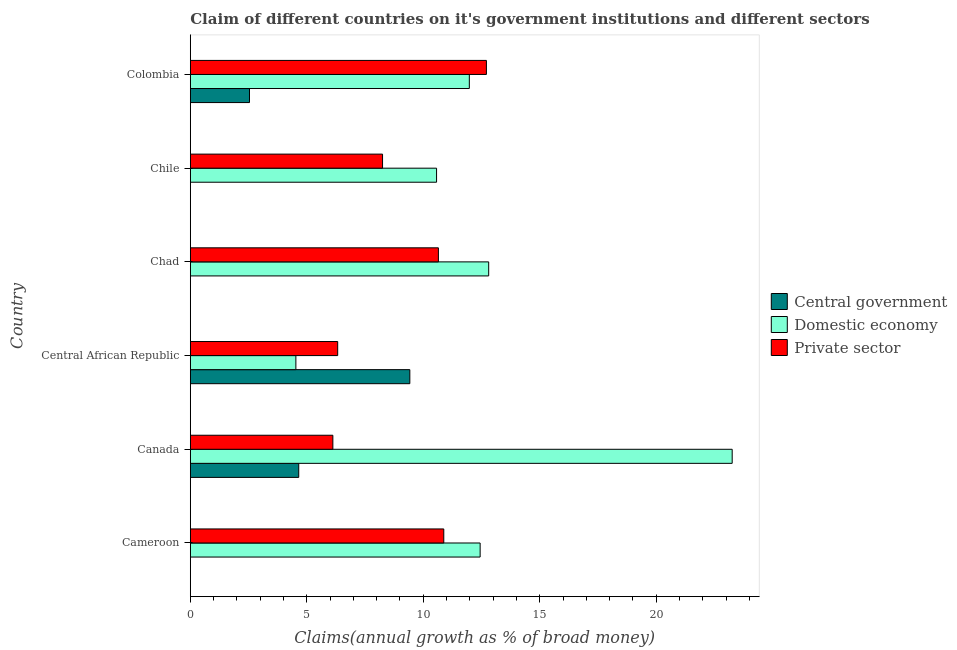Are the number of bars per tick equal to the number of legend labels?
Offer a terse response. No. Are the number of bars on each tick of the Y-axis equal?
Provide a short and direct response. No. How many bars are there on the 1st tick from the top?
Give a very brief answer. 3. How many bars are there on the 2nd tick from the bottom?
Offer a very short reply. 3. What is the label of the 5th group of bars from the top?
Your answer should be very brief. Canada. In how many cases, is the number of bars for a given country not equal to the number of legend labels?
Your answer should be very brief. 3. What is the percentage of claim on the domestic economy in Colombia?
Your answer should be very brief. 11.98. Across all countries, what is the maximum percentage of claim on the central government?
Your answer should be compact. 9.42. Across all countries, what is the minimum percentage of claim on the domestic economy?
Provide a succinct answer. 4.53. In which country was the percentage of claim on the domestic economy maximum?
Keep it short and to the point. Canada. What is the total percentage of claim on the central government in the graph?
Your answer should be very brief. 16.62. What is the difference between the percentage of claim on the domestic economy in Cameroon and that in Chad?
Your answer should be very brief. -0.37. What is the difference between the percentage of claim on the domestic economy in Central African Republic and the percentage of claim on the central government in Chile?
Provide a succinct answer. 4.53. What is the average percentage of claim on the domestic economy per country?
Provide a succinct answer. 12.6. What is the difference between the percentage of claim on the domestic economy and percentage of claim on the private sector in Central African Republic?
Keep it short and to the point. -1.79. In how many countries, is the percentage of claim on the private sector greater than 19 %?
Ensure brevity in your answer.  0. What is the ratio of the percentage of claim on the domestic economy in Canada to that in Colombia?
Give a very brief answer. 1.94. What is the difference between the highest and the second highest percentage of claim on the domestic economy?
Give a very brief answer. 10.45. What is the difference between the highest and the lowest percentage of claim on the domestic economy?
Your answer should be very brief. 18.73. In how many countries, is the percentage of claim on the central government greater than the average percentage of claim on the central government taken over all countries?
Give a very brief answer. 2. Is it the case that in every country, the sum of the percentage of claim on the central government and percentage of claim on the domestic economy is greater than the percentage of claim on the private sector?
Offer a terse response. Yes. How many bars are there?
Your response must be concise. 15. How many countries are there in the graph?
Ensure brevity in your answer.  6. Are the values on the major ticks of X-axis written in scientific E-notation?
Provide a succinct answer. No. Does the graph contain any zero values?
Your response must be concise. Yes. Where does the legend appear in the graph?
Provide a short and direct response. Center right. How many legend labels are there?
Offer a very short reply. 3. How are the legend labels stacked?
Provide a succinct answer. Vertical. What is the title of the graph?
Your answer should be very brief. Claim of different countries on it's government institutions and different sectors. Does "Ireland" appear as one of the legend labels in the graph?
Provide a succinct answer. No. What is the label or title of the X-axis?
Keep it short and to the point. Claims(annual growth as % of broad money). What is the label or title of the Y-axis?
Offer a very short reply. Country. What is the Claims(annual growth as % of broad money) in Domestic economy in Cameroon?
Make the answer very short. 12.44. What is the Claims(annual growth as % of broad money) in Private sector in Cameroon?
Your answer should be compact. 10.88. What is the Claims(annual growth as % of broad money) of Central government in Canada?
Keep it short and to the point. 4.65. What is the Claims(annual growth as % of broad money) of Domestic economy in Canada?
Make the answer very short. 23.26. What is the Claims(annual growth as % of broad money) of Private sector in Canada?
Provide a succinct answer. 6.12. What is the Claims(annual growth as % of broad money) of Central government in Central African Republic?
Your answer should be very brief. 9.42. What is the Claims(annual growth as % of broad money) of Domestic economy in Central African Republic?
Make the answer very short. 4.53. What is the Claims(annual growth as % of broad money) in Private sector in Central African Republic?
Provide a succinct answer. 6.33. What is the Claims(annual growth as % of broad money) of Domestic economy in Chad?
Your answer should be compact. 12.81. What is the Claims(annual growth as % of broad money) of Private sector in Chad?
Your response must be concise. 10.65. What is the Claims(annual growth as % of broad money) of Central government in Chile?
Provide a succinct answer. 0. What is the Claims(annual growth as % of broad money) in Domestic economy in Chile?
Offer a terse response. 10.57. What is the Claims(annual growth as % of broad money) of Private sector in Chile?
Offer a very short reply. 8.25. What is the Claims(annual growth as % of broad money) of Central government in Colombia?
Keep it short and to the point. 2.54. What is the Claims(annual growth as % of broad money) in Domestic economy in Colombia?
Offer a very short reply. 11.98. What is the Claims(annual growth as % of broad money) in Private sector in Colombia?
Your answer should be very brief. 12.71. Across all countries, what is the maximum Claims(annual growth as % of broad money) in Central government?
Ensure brevity in your answer.  9.42. Across all countries, what is the maximum Claims(annual growth as % of broad money) in Domestic economy?
Your response must be concise. 23.26. Across all countries, what is the maximum Claims(annual growth as % of broad money) in Private sector?
Provide a succinct answer. 12.71. Across all countries, what is the minimum Claims(annual growth as % of broad money) of Domestic economy?
Your response must be concise. 4.53. Across all countries, what is the minimum Claims(annual growth as % of broad money) in Private sector?
Ensure brevity in your answer.  6.12. What is the total Claims(annual growth as % of broad money) in Central government in the graph?
Offer a terse response. 16.62. What is the total Claims(annual growth as % of broad money) in Domestic economy in the graph?
Offer a very short reply. 75.6. What is the total Claims(annual growth as % of broad money) in Private sector in the graph?
Make the answer very short. 54.94. What is the difference between the Claims(annual growth as % of broad money) in Domestic economy in Cameroon and that in Canada?
Offer a very short reply. -10.82. What is the difference between the Claims(annual growth as % of broad money) of Private sector in Cameroon and that in Canada?
Your answer should be very brief. 4.76. What is the difference between the Claims(annual growth as % of broad money) of Domestic economy in Cameroon and that in Central African Republic?
Keep it short and to the point. 7.91. What is the difference between the Claims(annual growth as % of broad money) of Private sector in Cameroon and that in Central African Republic?
Your answer should be compact. 4.55. What is the difference between the Claims(annual growth as % of broad money) of Domestic economy in Cameroon and that in Chad?
Your answer should be very brief. -0.37. What is the difference between the Claims(annual growth as % of broad money) in Private sector in Cameroon and that in Chad?
Your response must be concise. 0.23. What is the difference between the Claims(annual growth as % of broad money) of Domestic economy in Cameroon and that in Chile?
Provide a short and direct response. 1.87. What is the difference between the Claims(annual growth as % of broad money) in Private sector in Cameroon and that in Chile?
Keep it short and to the point. 2.63. What is the difference between the Claims(annual growth as % of broad money) in Domestic economy in Cameroon and that in Colombia?
Provide a succinct answer. 0.46. What is the difference between the Claims(annual growth as % of broad money) of Private sector in Cameroon and that in Colombia?
Your response must be concise. -1.83. What is the difference between the Claims(annual growth as % of broad money) of Central government in Canada and that in Central African Republic?
Keep it short and to the point. -4.77. What is the difference between the Claims(annual growth as % of broad money) in Domestic economy in Canada and that in Central African Republic?
Offer a terse response. 18.73. What is the difference between the Claims(annual growth as % of broad money) of Private sector in Canada and that in Central African Republic?
Keep it short and to the point. -0.21. What is the difference between the Claims(annual growth as % of broad money) of Domestic economy in Canada and that in Chad?
Provide a succinct answer. 10.45. What is the difference between the Claims(annual growth as % of broad money) in Private sector in Canada and that in Chad?
Keep it short and to the point. -4.53. What is the difference between the Claims(annual growth as % of broad money) in Domestic economy in Canada and that in Chile?
Offer a very short reply. 12.69. What is the difference between the Claims(annual growth as % of broad money) in Private sector in Canada and that in Chile?
Your response must be concise. -2.13. What is the difference between the Claims(annual growth as % of broad money) in Central government in Canada and that in Colombia?
Provide a short and direct response. 2.11. What is the difference between the Claims(annual growth as % of broad money) of Domestic economy in Canada and that in Colombia?
Your answer should be compact. 11.28. What is the difference between the Claims(annual growth as % of broad money) in Private sector in Canada and that in Colombia?
Ensure brevity in your answer.  -6.59. What is the difference between the Claims(annual growth as % of broad money) in Domestic economy in Central African Republic and that in Chad?
Give a very brief answer. -8.28. What is the difference between the Claims(annual growth as % of broad money) of Private sector in Central African Republic and that in Chad?
Provide a short and direct response. -4.32. What is the difference between the Claims(annual growth as % of broad money) of Domestic economy in Central African Republic and that in Chile?
Offer a terse response. -6.04. What is the difference between the Claims(annual growth as % of broad money) of Private sector in Central African Republic and that in Chile?
Provide a short and direct response. -1.93. What is the difference between the Claims(annual growth as % of broad money) in Central government in Central African Republic and that in Colombia?
Give a very brief answer. 6.88. What is the difference between the Claims(annual growth as % of broad money) of Domestic economy in Central African Republic and that in Colombia?
Provide a succinct answer. -7.45. What is the difference between the Claims(annual growth as % of broad money) of Private sector in Central African Republic and that in Colombia?
Provide a succinct answer. -6.38. What is the difference between the Claims(annual growth as % of broad money) of Domestic economy in Chad and that in Chile?
Your response must be concise. 2.24. What is the difference between the Claims(annual growth as % of broad money) of Private sector in Chad and that in Chile?
Provide a succinct answer. 2.4. What is the difference between the Claims(annual growth as % of broad money) in Domestic economy in Chad and that in Colombia?
Make the answer very short. 0.83. What is the difference between the Claims(annual growth as % of broad money) in Private sector in Chad and that in Colombia?
Provide a succinct answer. -2.06. What is the difference between the Claims(annual growth as % of broad money) in Domestic economy in Chile and that in Colombia?
Make the answer very short. -1.41. What is the difference between the Claims(annual growth as % of broad money) of Private sector in Chile and that in Colombia?
Offer a very short reply. -4.46. What is the difference between the Claims(annual growth as % of broad money) in Domestic economy in Cameroon and the Claims(annual growth as % of broad money) in Private sector in Canada?
Offer a terse response. 6.32. What is the difference between the Claims(annual growth as % of broad money) of Domestic economy in Cameroon and the Claims(annual growth as % of broad money) of Private sector in Central African Republic?
Provide a succinct answer. 6.11. What is the difference between the Claims(annual growth as % of broad money) in Domestic economy in Cameroon and the Claims(annual growth as % of broad money) in Private sector in Chad?
Ensure brevity in your answer.  1.79. What is the difference between the Claims(annual growth as % of broad money) of Domestic economy in Cameroon and the Claims(annual growth as % of broad money) of Private sector in Chile?
Make the answer very short. 4.19. What is the difference between the Claims(annual growth as % of broad money) in Domestic economy in Cameroon and the Claims(annual growth as % of broad money) in Private sector in Colombia?
Offer a very short reply. -0.27. What is the difference between the Claims(annual growth as % of broad money) in Central government in Canada and the Claims(annual growth as % of broad money) in Domestic economy in Central African Republic?
Make the answer very short. 0.12. What is the difference between the Claims(annual growth as % of broad money) in Central government in Canada and the Claims(annual growth as % of broad money) in Private sector in Central African Republic?
Ensure brevity in your answer.  -1.67. What is the difference between the Claims(annual growth as % of broad money) in Domestic economy in Canada and the Claims(annual growth as % of broad money) in Private sector in Central African Republic?
Provide a succinct answer. 16.93. What is the difference between the Claims(annual growth as % of broad money) in Central government in Canada and the Claims(annual growth as % of broad money) in Domestic economy in Chad?
Provide a succinct answer. -8.15. What is the difference between the Claims(annual growth as % of broad money) of Central government in Canada and the Claims(annual growth as % of broad money) of Private sector in Chad?
Provide a short and direct response. -6. What is the difference between the Claims(annual growth as % of broad money) of Domestic economy in Canada and the Claims(annual growth as % of broad money) of Private sector in Chad?
Offer a very short reply. 12.61. What is the difference between the Claims(annual growth as % of broad money) of Central government in Canada and the Claims(annual growth as % of broad money) of Domestic economy in Chile?
Offer a very short reply. -5.92. What is the difference between the Claims(annual growth as % of broad money) of Central government in Canada and the Claims(annual growth as % of broad money) of Private sector in Chile?
Your answer should be very brief. -3.6. What is the difference between the Claims(annual growth as % of broad money) in Domestic economy in Canada and the Claims(annual growth as % of broad money) in Private sector in Chile?
Give a very brief answer. 15.01. What is the difference between the Claims(annual growth as % of broad money) in Central government in Canada and the Claims(annual growth as % of broad money) in Domestic economy in Colombia?
Offer a terse response. -7.32. What is the difference between the Claims(annual growth as % of broad money) of Central government in Canada and the Claims(annual growth as % of broad money) of Private sector in Colombia?
Ensure brevity in your answer.  -8.06. What is the difference between the Claims(annual growth as % of broad money) of Domestic economy in Canada and the Claims(annual growth as % of broad money) of Private sector in Colombia?
Keep it short and to the point. 10.55. What is the difference between the Claims(annual growth as % of broad money) of Central government in Central African Republic and the Claims(annual growth as % of broad money) of Domestic economy in Chad?
Your response must be concise. -3.39. What is the difference between the Claims(annual growth as % of broad money) in Central government in Central African Republic and the Claims(annual growth as % of broad money) in Private sector in Chad?
Provide a succinct answer. -1.23. What is the difference between the Claims(annual growth as % of broad money) of Domestic economy in Central African Republic and the Claims(annual growth as % of broad money) of Private sector in Chad?
Offer a very short reply. -6.12. What is the difference between the Claims(annual growth as % of broad money) in Central government in Central African Republic and the Claims(annual growth as % of broad money) in Domestic economy in Chile?
Your answer should be compact. -1.15. What is the difference between the Claims(annual growth as % of broad money) in Central government in Central African Republic and the Claims(annual growth as % of broad money) in Private sector in Chile?
Give a very brief answer. 1.17. What is the difference between the Claims(annual growth as % of broad money) of Domestic economy in Central African Republic and the Claims(annual growth as % of broad money) of Private sector in Chile?
Your answer should be compact. -3.72. What is the difference between the Claims(annual growth as % of broad money) in Central government in Central African Republic and the Claims(annual growth as % of broad money) in Domestic economy in Colombia?
Offer a terse response. -2.55. What is the difference between the Claims(annual growth as % of broad money) of Central government in Central African Republic and the Claims(annual growth as % of broad money) of Private sector in Colombia?
Your answer should be compact. -3.29. What is the difference between the Claims(annual growth as % of broad money) in Domestic economy in Central African Republic and the Claims(annual growth as % of broad money) in Private sector in Colombia?
Offer a very short reply. -8.18. What is the difference between the Claims(annual growth as % of broad money) of Domestic economy in Chad and the Claims(annual growth as % of broad money) of Private sector in Chile?
Make the answer very short. 4.56. What is the difference between the Claims(annual growth as % of broad money) of Domestic economy in Chad and the Claims(annual growth as % of broad money) of Private sector in Colombia?
Make the answer very short. 0.1. What is the difference between the Claims(annual growth as % of broad money) of Domestic economy in Chile and the Claims(annual growth as % of broad money) of Private sector in Colombia?
Keep it short and to the point. -2.14. What is the average Claims(annual growth as % of broad money) in Central government per country?
Provide a succinct answer. 2.77. What is the average Claims(annual growth as % of broad money) in Domestic economy per country?
Provide a short and direct response. 12.6. What is the average Claims(annual growth as % of broad money) of Private sector per country?
Offer a very short reply. 9.16. What is the difference between the Claims(annual growth as % of broad money) in Domestic economy and Claims(annual growth as % of broad money) in Private sector in Cameroon?
Ensure brevity in your answer.  1.56. What is the difference between the Claims(annual growth as % of broad money) in Central government and Claims(annual growth as % of broad money) in Domestic economy in Canada?
Provide a succinct answer. -18.61. What is the difference between the Claims(annual growth as % of broad money) in Central government and Claims(annual growth as % of broad money) in Private sector in Canada?
Give a very brief answer. -1.47. What is the difference between the Claims(annual growth as % of broad money) in Domestic economy and Claims(annual growth as % of broad money) in Private sector in Canada?
Provide a succinct answer. 17.14. What is the difference between the Claims(annual growth as % of broad money) in Central government and Claims(annual growth as % of broad money) in Domestic economy in Central African Republic?
Ensure brevity in your answer.  4.89. What is the difference between the Claims(annual growth as % of broad money) of Central government and Claims(annual growth as % of broad money) of Private sector in Central African Republic?
Give a very brief answer. 3.1. What is the difference between the Claims(annual growth as % of broad money) of Domestic economy and Claims(annual growth as % of broad money) of Private sector in Central African Republic?
Provide a short and direct response. -1.79. What is the difference between the Claims(annual growth as % of broad money) of Domestic economy and Claims(annual growth as % of broad money) of Private sector in Chad?
Your answer should be very brief. 2.16. What is the difference between the Claims(annual growth as % of broad money) in Domestic economy and Claims(annual growth as % of broad money) in Private sector in Chile?
Your answer should be compact. 2.32. What is the difference between the Claims(annual growth as % of broad money) in Central government and Claims(annual growth as % of broad money) in Domestic economy in Colombia?
Keep it short and to the point. -9.44. What is the difference between the Claims(annual growth as % of broad money) in Central government and Claims(annual growth as % of broad money) in Private sector in Colombia?
Make the answer very short. -10.17. What is the difference between the Claims(annual growth as % of broad money) in Domestic economy and Claims(annual growth as % of broad money) in Private sector in Colombia?
Ensure brevity in your answer.  -0.73. What is the ratio of the Claims(annual growth as % of broad money) of Domestic economy in Cameroon to that in Canada?
Give a very brief answer. 0.53. What is the ratio of the Claims(annual growth as % of broad money) of Private sector in Cameroon to that in Canada?
Provide a succinct answer. 1.78. What is the ratio of the Claims(annual growth as % of broad money) in Domestic economy in Cameroon to that in Central African Republic?
Your response must be concise. 2.75. What is the ratio of the Claims(annual growth as % of broad money) in Private sector in Cameroon to that in Central African Republic?
Make the answer very short. 1.72. What is the ratio of the Claims(annual growth as % of broad money) in Domestic economy in Cameroon to that in Chad?
Offer a very short reply. 0.97. What is the ratio of the Claims(annual growth as % of broad money) of Private sector in Cameroon to that in Chad?
Give a very brief answer. 1.02. What is the ratio of the Claims(annual growth as % of broad money) of Domestic economy in Cameroon to that in Chile?
Offer a very short reply. 1.18. What is the ratio of the Claims(annual growth as % of broad money) in Private sector in Cameroon to that in Chile?
Offer a very short reply. 1.32. What is the ratio of the Claims(annual growth as % of broad money) in Domestic economy in Cameroon to that in Colombia?
Your response must be concise. 1.04. What is the ratio of the Claims(annual growth as % of broad money) of Private sector in Cameroon to that in Colombia?
Make the answer very short. 0.86. What is the ratio of the Claims(annual growth as % of broad money) of Central government in Canada to that in Central African Republic?
Ensure brevity in your answer.  0.49. What is the ratio of the Claims(annual growth as % of broad money) in Domestic economy in Canada to that in Central African Republic?
Keep it short and to the point. 5.13. What is the ratio of the Claims(annual growth as % of broad money) of Private sector in Canada to that in Central African Republic?
Keep it short and to the point. 0.97. What is the ratio of the Claims(annual growth as % of broad money) in Domestic economy in Canada to that in Chad?
Offer a terse response. 1.82. What is the ratio of the Claims(annual growth as % of broad money) in Private sector in Canada to that in Chad?
Provide a short and direct response. 0.57. What is the ratio of the Claims(annual growth as % of broad money) in Domestic economy in Canada to that in Chile?
Keep it short and to the point. 2.2. What is the ratio of the Claims(annual growth as % of broad money) of Private sector in Canada to that in Chile?
Make the answer very short. 0.74. What is the ratio of the Claims(annual growth as % of broad money) of Central government in Canada to that in Colombia?
Your response must be concise. 1.83. What is the ratio of the Claims(annual growth as % of broad money) in Domestic economy in Canada to that in Colombia?
Keep it short and to the point. 1.94. What is the ratio of the Claims(annual growth as % of broad money) of Private sector in Canada to that in Colombia?
Provide a succinct answer. 0.48. What is the ratio of the Claims(annual growth as % of broad money) of Domestic economy in Central African Republic to that in Chad?
Provide a succinct answer. 0.35. What is the ratio of the Claims(annual growth as % of broad money) in Private sector in Central African Republic to that in Chad?
Offer a very short reply. 0.59. What is the ratio of the Claims(annual growth as % of broad money) in Domestic economy in Central African Republic to that in Chile?
Offer a terse response. 0.43. What is the ratio of the Claims(annual growth as % of broad money) of Private sector in Central African Republic to that in Chile?
Keep it short and to the point. 0.77. What is the ratio of the Claims(annual growth as % of broad money) of Central government in Central African Republic to that in Colombia?
Provide a short and direct response. 3.71. What is the ratio of the Claims(annual growth as % of broad money) in Domestic economy in Central African Republic to that in Colombia?
Offer a very short reply. 0.38. What is the ratio of the Claims(annual growth as % of broad money) of Private sector in Central African Republic to that in Colombia?
Provide a succinct answer. 0.5. What is the ratio of the Claims(annual growth as % of broad money) in Domestic economy in Chad to that in Chile?
Provide a succinct answer. 1.21. What is the ratio of the Claims(annual growth as % of broad money) of Private sector in Chad to that in Chile?
Make the answer very short. 1.29. What is the ratio of the Claims(annual growth as % of broad money) of Domestic economy in Chad to that in Colombia?
Offer a terse response. 1.07. What is the ratio of the Claims(annual growth as % of broad money) in Private sector in Chad to that in Colombia?
Make the answer very short. 0.84. What is the ratio of the Claims(annual growth as % of broad money) in Domestic economy in Chile to that in Colombia?
Give a very brief answer. 0.88. What is the ratio of the Claims(annual growth as % of broad money) in Private sector in Chile to that in Colombia?
Keep it short and to the point. 0.65. What is the difference between the highest and the second highest Claims(annual growth as % of broad money) in Central government?
Give a very brief answer. 4.77. What is the difference between the highest and the second highest Claims(annual growth as % of broad money) of Domestic economy?
Make the answer very short. 10.45. What is the difference between the highest and the second highest Claims(annual growth as % of broad money) in Private sector?
Offer a terse response. 1.83. What is the difference between the highest and the lowest Claims(annual growth as % of broad money) of Central government?
Your answer should be very brief. 9.42. What is the difference between the highest and the lowest Claims(annual growth as % of broad money) of Domestic economy?
Offer a terse response. 18.73. What is the difference between the highest and the lowest Claims(annual growth as % of broad money) in Private sector?
Ensure brevity in your answer.  6.59. 